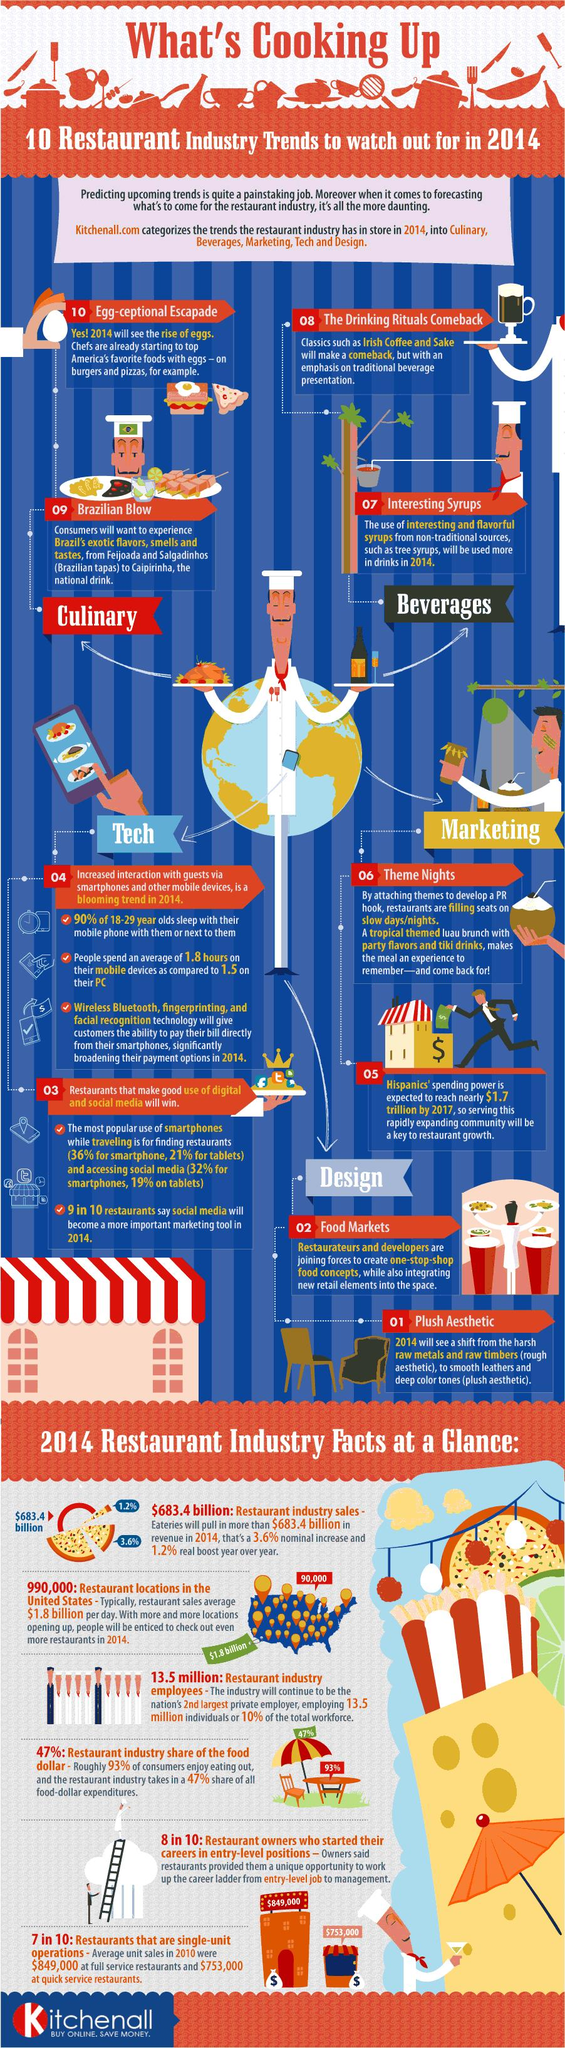Mention a couple of crucial points in this snapshot. According to a recent survey, approximately 30% of restaurants operate as a franchise system, meaning they do not operate as a single unit. The average amount of time spent on a smartphone is higher than the average amount of time spent on a PC. There are six restaurant industry facts provided in the bottom section of the infographic. In 2014, three technologies may have assisted customers in paying their bills: wireless Bluetooth and fingerprinting technology. According to research, 10% of 18-29 year olds sleep without having their smart phone within reach. 